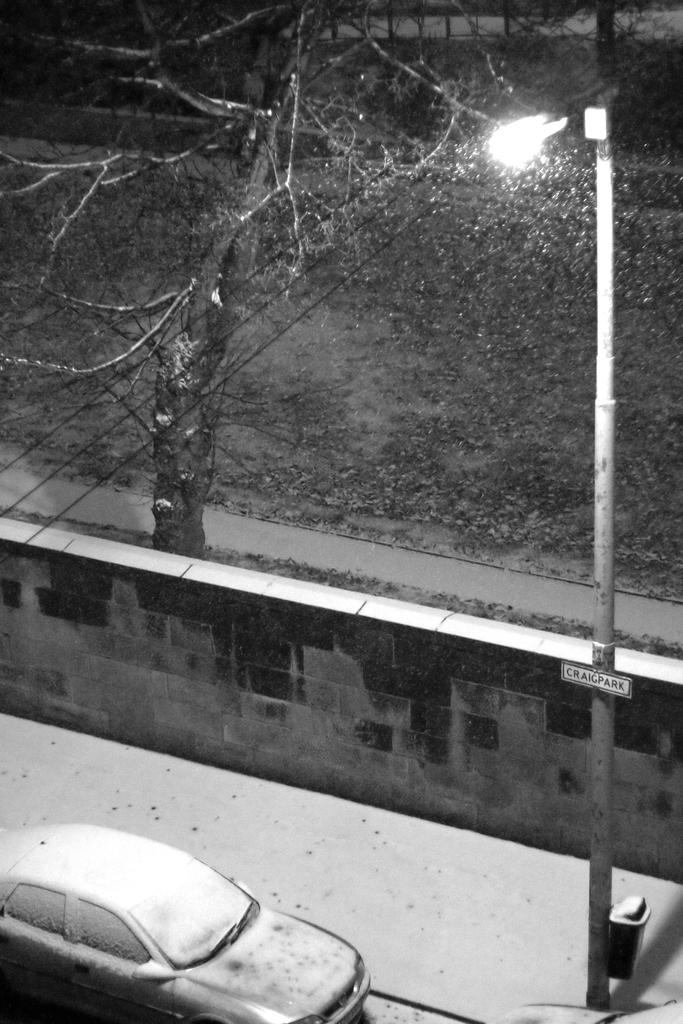What structure is located on the right side of the image? There is a pole on the right side of the image. What type of vehicle is at the bottom of the image? There is a car at the bottom of the image. What can be seen in the background of the image? There is a wall and a tree in the background of the image. What is the opinion of the twig about the dress in the image? There is no twig or dress present in the image, so it is not possible to determine any opinions about a dress. 